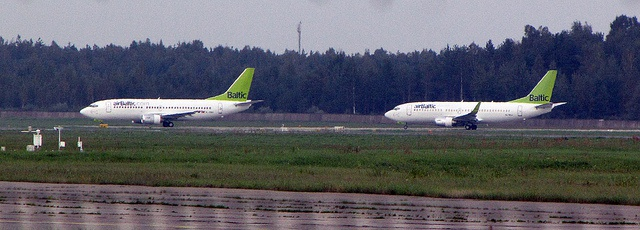Describe the objects in this image and their specific colors. I can see airplane in darkgray, lightgray, gray, and navy tones and airplane in darkgray, white, gray, and olive tones in this image. 